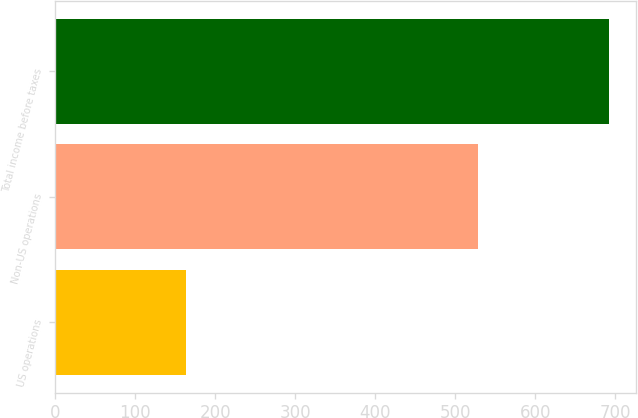<chart> <loc_0><loc_0><loc_500><loc_500><bar_chart><fcel>US operations<fcel>Non-US operations<fcel>Total income before taxes<nl><fcel>163<fcel>529<fcel>692<nl></chart> 